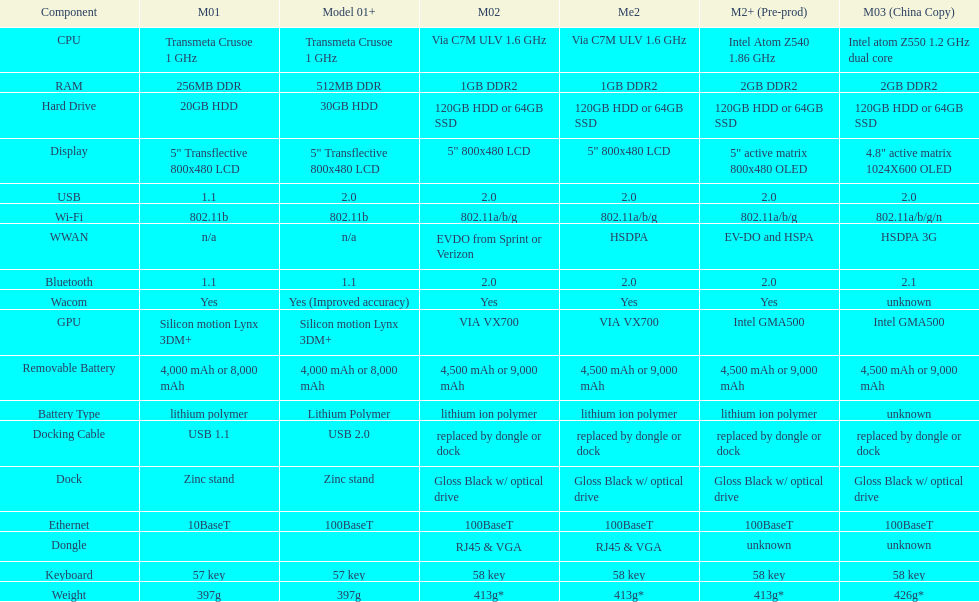What component comes after bluetooth? Wacom. 